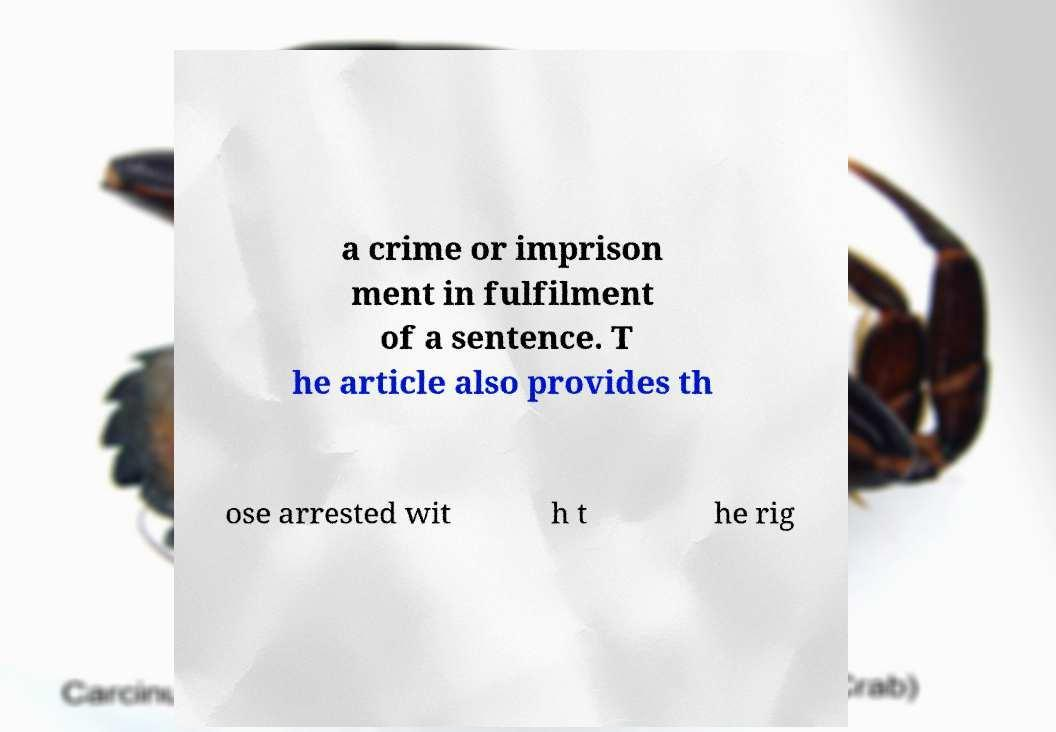I need the written content from this picture converted into text. Can you do that? a crime or imprison ment in fulfilment of a sentence. T he article also provides th ose arrested wit h t he rig 